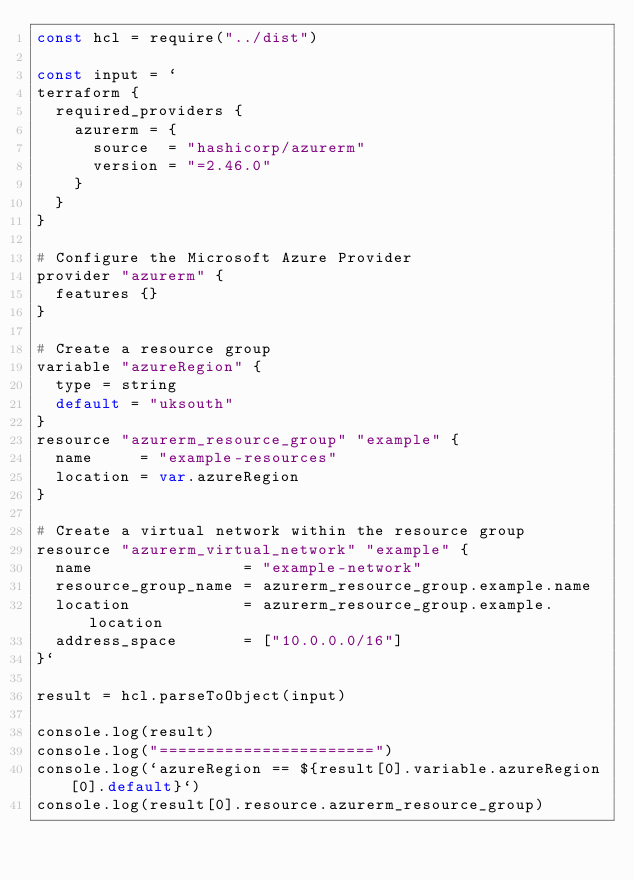<code> <loc_0><loc_0><loc_500><loc_500><_JavaScript_>const hcl = require("../dist")

const input = `
terraform {
  required_providers {
    azurerm = {
      source  = "hashicorp/azurerm"
      version = "=2.46.0"
    }
  }
}

# Configure the Microsoft Azure Provider
provider "azurerm" {
  features {}
}

# Create a resource group
variable "azureRegion" {
  type = string
  default = "uksouth"
}
resource "azurerm_resource_group" "example" {
  name     = "example-resources"
  location = var.azureRegion
}

# Create a virtual network within the resource group
resource "azurerm_virtual_network" "example" {
  name                = "example-network"
  resource_group_name = azurerm_resource_group.example.name
  location            = azurerm_resource_group.example.location
  address_space       = ["10.0.0.0/16"]
}`

result = hcl.parseToObject(input)

console.log(result)
console.log("=======================")
console.log(`azureRegion == ${result[0].variable.azureRegion[0].default}`)
console.log(result[0].resource.azurerm_resource_group)
</code> 